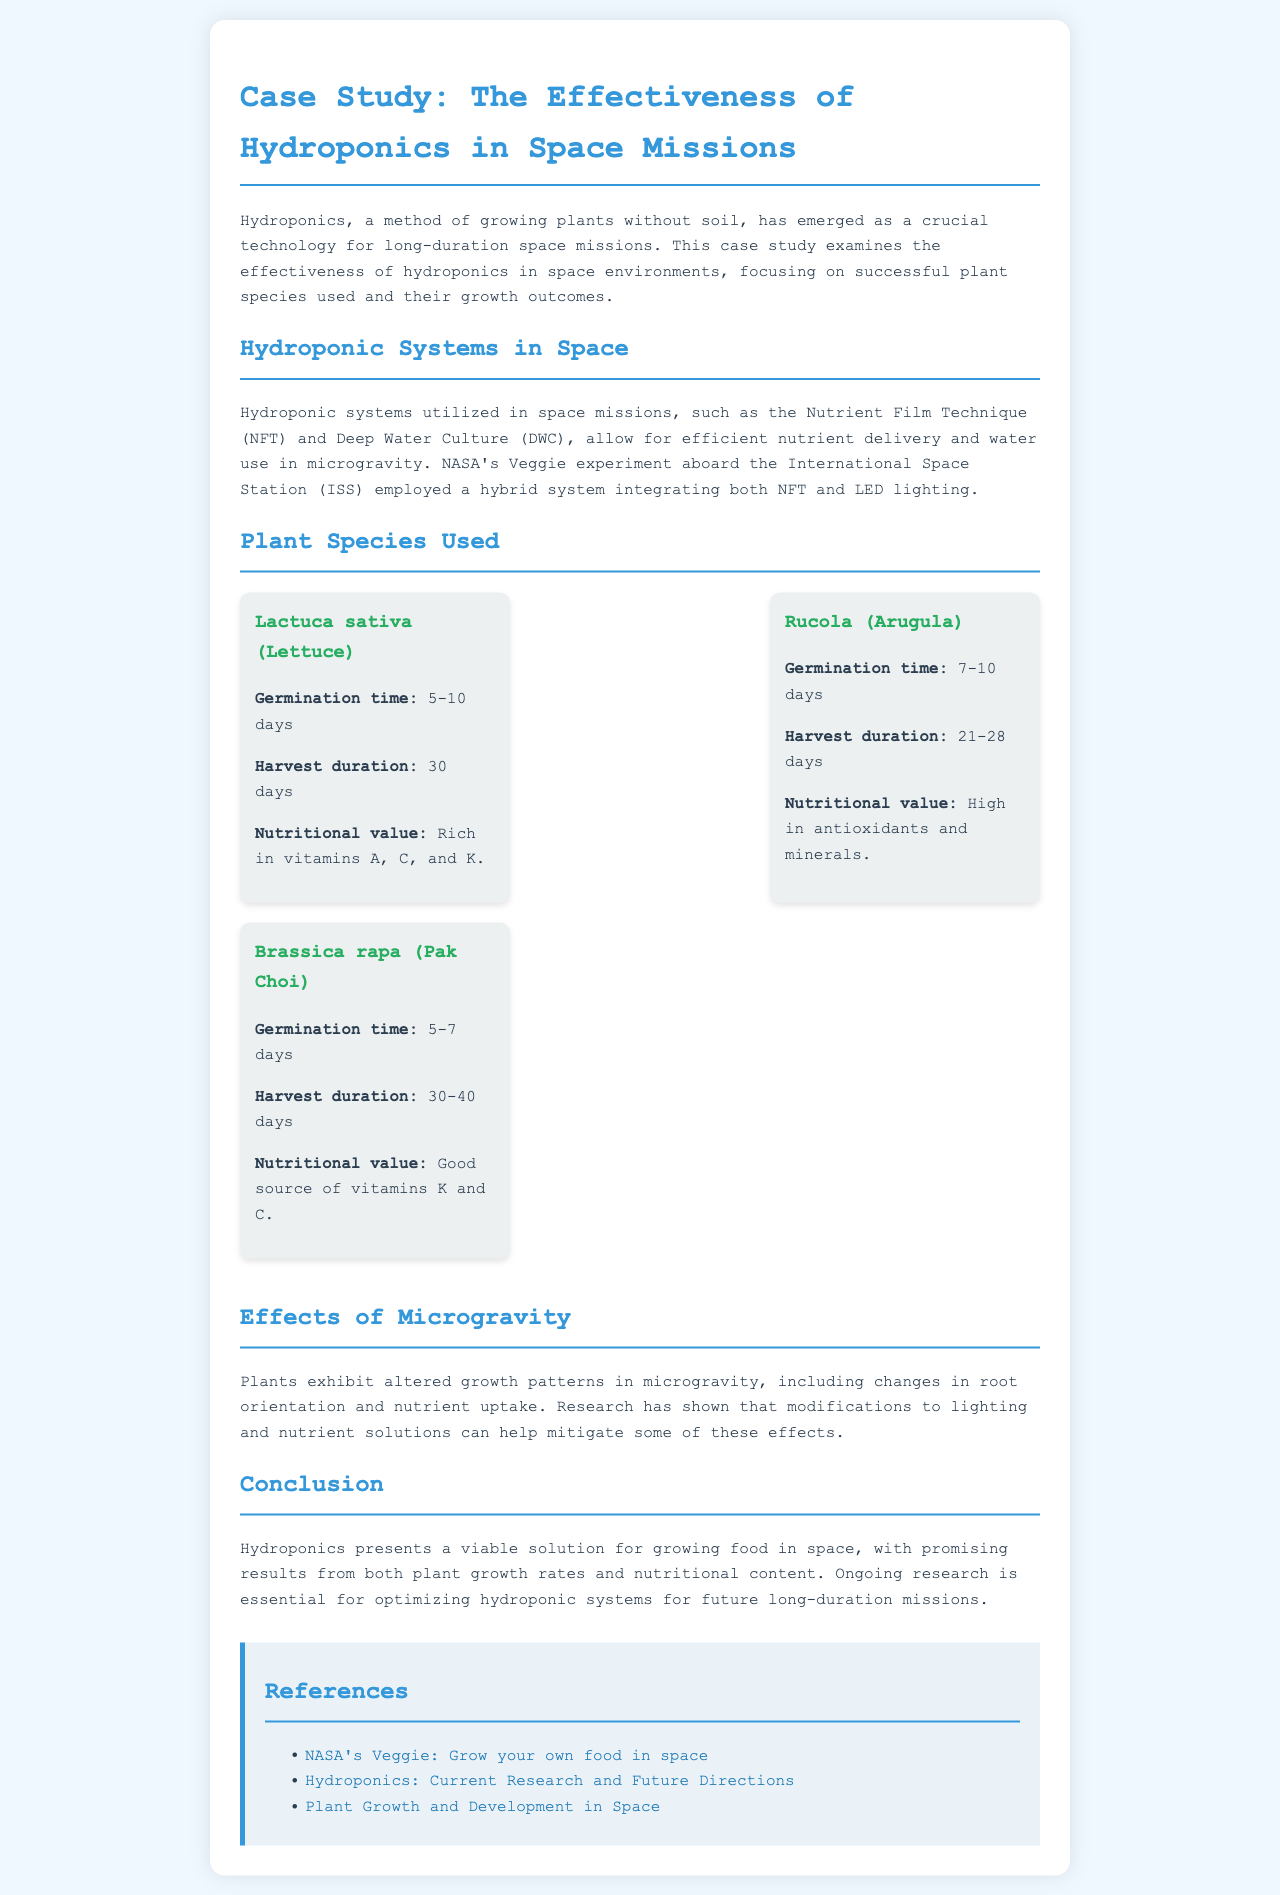what is the main growing method discussed in the document? The document primarily discusses a method of growing plants without soil known as hydroponics.
Answer: hydroponics what plant species is mentioned that has a germination time of 5-10 days? The document lists Lactuca sativa, or lettuce, which has a germination time of 5-10 days.
Answer: Lactuca sativa how long does it take to harvest Rucola (Arugula)? According to the document, Rucola can be harvested in 21-28 days.
Answer: 21-28 days what are the two hydroponic systems utilized in space missions mentioned in the document? The document mentions the Nutrient Film Technique (NFT) and Deep Water Culture (DWC) as the two hydroponic systems used in space.
Answer: Nutrient Film Technique and Deep Water Culture which plant species listed is a good source of vitamins K and C? The document identifies Brassica rapa (Pak Choi) as a good source of vitamins K and C.
Answer: Brassica rapa how does microgravity affect plant growth patterns? The document states that plants exhibit altered growth patterns in microgravity, including changes in root orientation and nutrient uptake.
Answer: altered growth patterns what is the goal of ongoing research in hydroponics for space missions? The document emphasizes that ongoing research aims to optimize hydroponic systems for future long-duration missions.
Answer: optimize hydroponic systems what type of content does the conclusion of the document emphasize? The conclusion highlights that hydroponics presents a viable solution for growing food in space with promising results from plant growth rates and nutritional content.
Answer: viable solution for growing food in space 